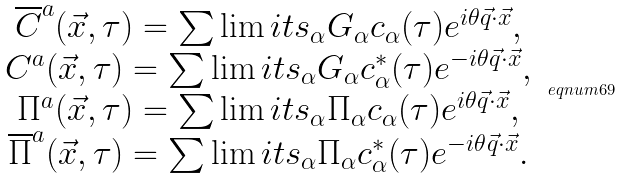<formula> <loc_0><loc_0><loc_500><loc_500>\begin{array} { c } \overline { C } ^ { a } ( \vec { x } , \tau ) = \sum \lim i t s _ { \alpha } G _ { \alpha } c _ { \alpha } ( \tau ) e ^ { i \theta \vec { q } \cdot \vec { x } } , \\ C ^ { a } ( \vec { x } , \tau ) = \sum \lim i t s _ { \alpha } G _ { \alpha } c _ { \alpha } ^ { * } ( \tau ) e ^ { - i \theta \vec { q } \cdot \vec { x } } , \\ \Pi ^ { a } ( \vec { x } , \tau ) = \sum \lim i t s _ { \alpha } \Pi _ { \alpha } c _ { \alpha } ( \tau ) e ^ { i \theta \vec { q } \cdot \vec { x } } , \\ \overline { \Pi } ^ { a } ( \vec { x } , \tau ) = \sum \lim i t s _ { \alpha } \Pi _ { \alpha } c _ { \alpha } ^ { * } ( \tau ) e ^ { - i \theta \vec { q } \cdot \vec { x } } . \end{array} \ e q n u m { 6 9 }</formula> 